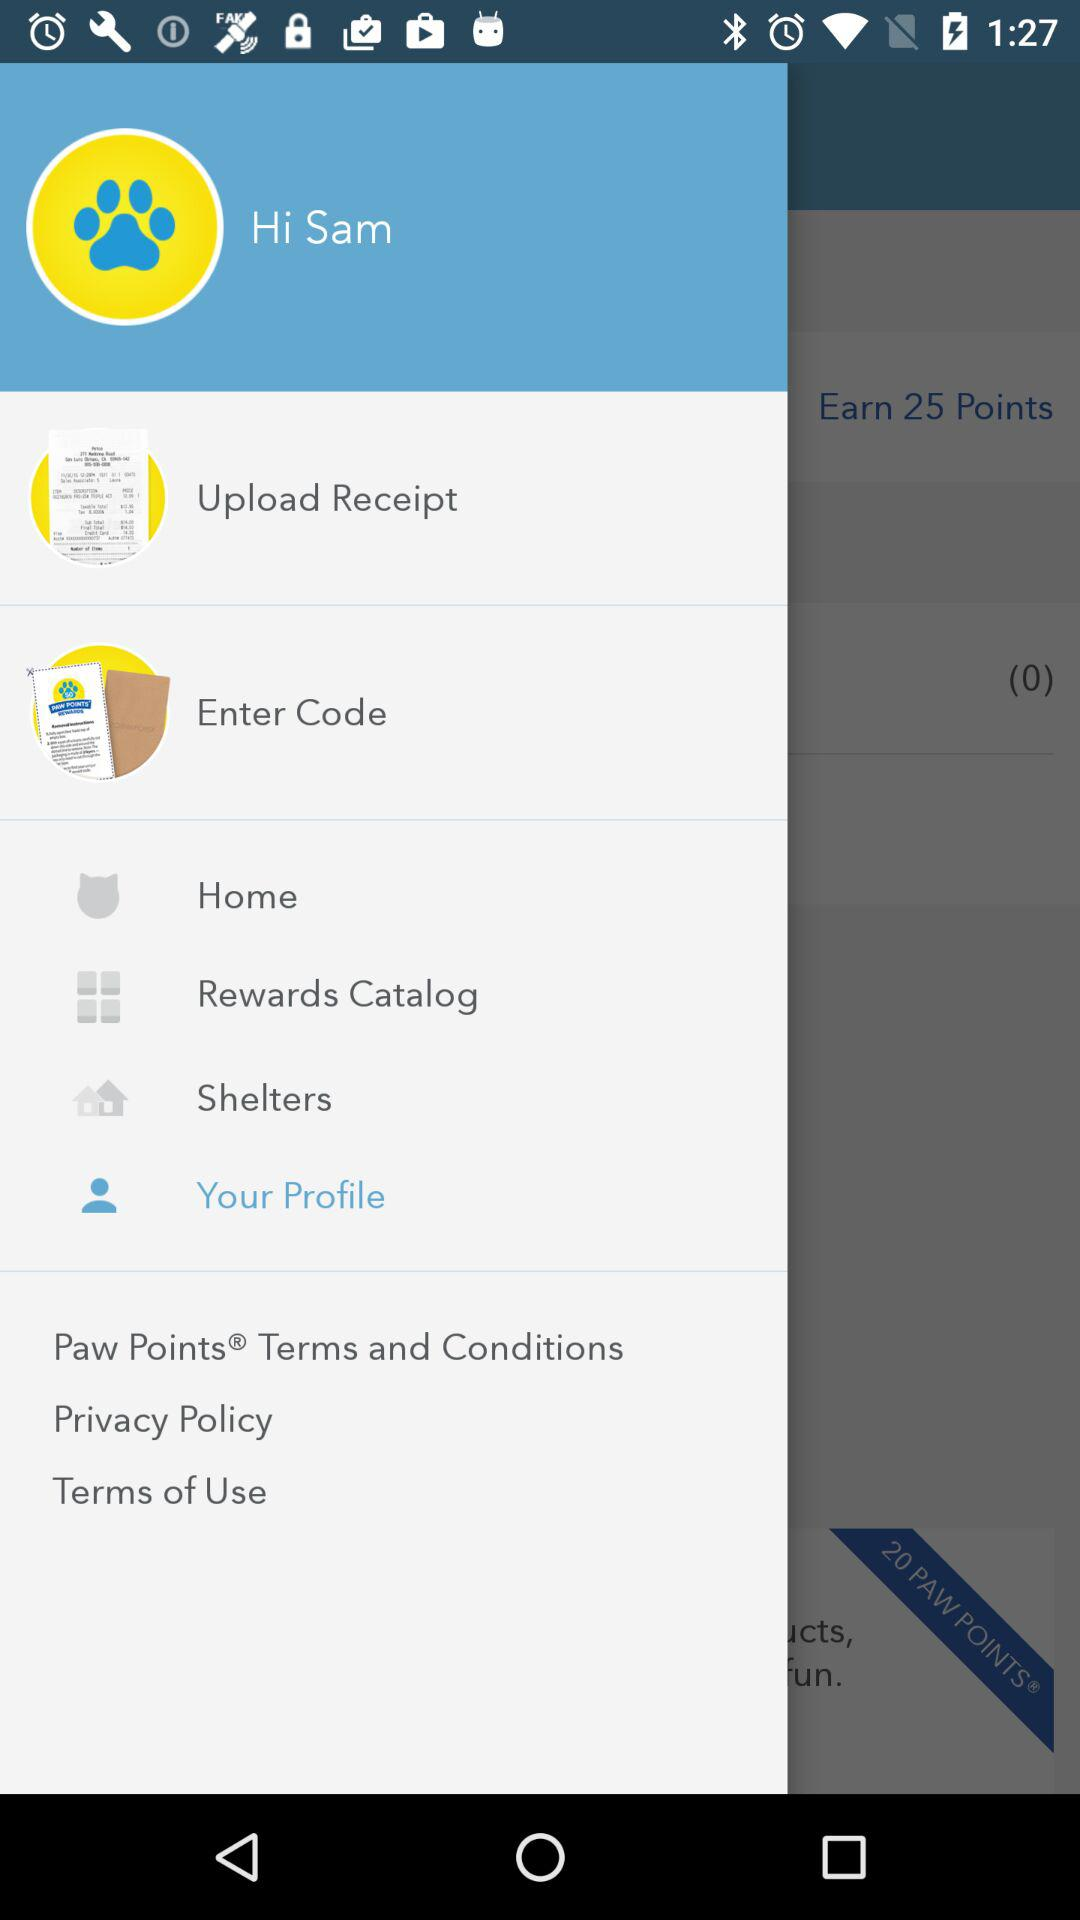Which item is selected? The selected item is "Your Profile". 